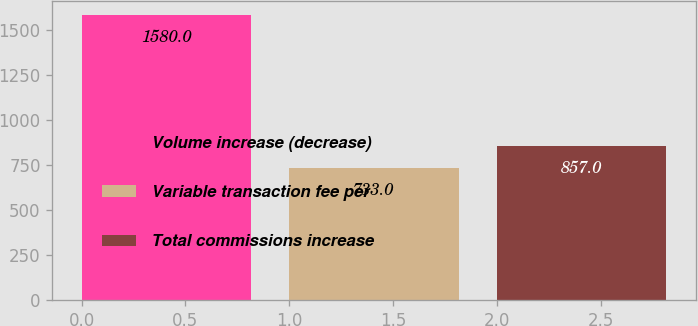Convert chart. <chart><loc_0><loc_0><loc_500><loc_500><bar_chart><fcel>Volume increase (decrease)<fcel>Variable transaction fee per<fcel>Total commissions increase<nl><fcel>1580<fcel>733<fcel>857<nl></chart> 